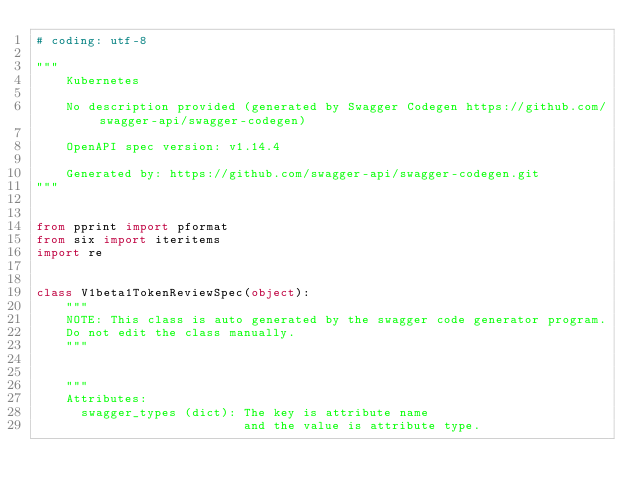<code> <loc_0><loc_0><loc_500><loc_500><_Python_># coding: utf-8

"""
    Kubernetes

    No description provided (generated by Swagger Codegen https://github.com/swagger-api/swagger-codegen)

    OpenAPI spec version: v1.14.4
    
    Generated by: https://github.com/swagger-api/swagger-codegen.git
"""


from pprint import pformat
from six import iteritems
import re


class V1beta1TokenReviewSpec(object):
    """
    NOTE: This class is auto generated by the swagger code generator program.
    Do not edit the class manually.
    """


    """
    Attributes:
      swagger_types (dict): The key is attribute name
                            and the value is attribute type.</code> 